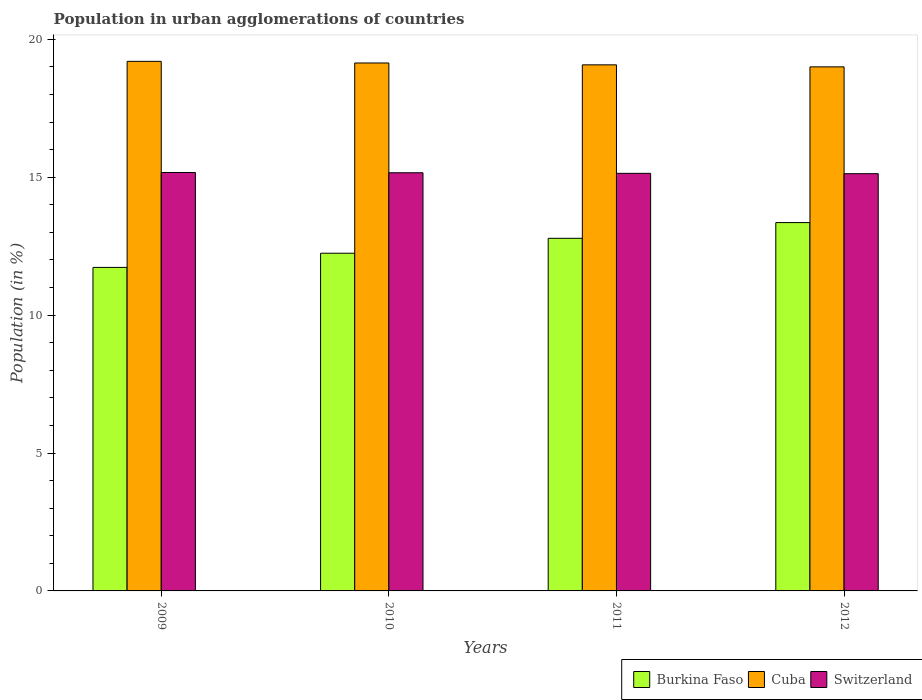How many different coloured bars are there?
Provide a short and direct response. 3. How many bars are there on the 2nd tick from the left?
Ensure brevity in your answer.  3. How many bars are there on the 3rd tick from the right?
Your response must be concise. 3. What is the label of the 4th group of bars from the left?
Offer a very short reply. 2012. In how many cases, is the number of bars for a given year not equal to the number of legend labels?
Keep it short and to the point. 0. What is the percentage of population in urban agglomerations in Switzerland in 2012?
Make the answer very short. 15.13. Across all years, what is the maximum percentage of population in urban agglomerations in Burkina Faso?
Keep it short and to the point. 13.36. Across all years, what is the minimum percentage of population in urban agglomerations in Burkina Faso?
Give a very brief answer. 11.73. In which year was the percentage of population in urban agglomerations in Cuba maximum?
Your response must be concise. 2009. What is the total percentage of population in urban agglomerations in Switzerland in the graph?
Provide a short and direct response. 60.61. What is the difference between the percentage of population in urban agglomerations in Switzerland in 2010 and that in 2012?
Give a very brief answer. 0.03. What is the difference between the percentage of population in urban agglomerations in Cuba in 2011 and the percentage of population in urban agglomerations in Switzerland in 2010?
Offer a very short reply. 3.91. What is the average percentage of population in urban agglomerations in Burkina Faso per year?
Your response must be concise. 12.53. In the year 2010, what is the difference between the percentage of population in urban agglomerations in Cuba and percentage of population in urban agglomerations in Burkina Faso?
Give a very brief answer. 6.9. What is the ratio of the percentage of population in urban agglomerations in Cuba in 2011 to that in 2012?
Offer a very short reply. 1. Is the difference between the percentage of population in urban agglomerations in Cuba in 2010 and 2011 greater than the difference between the percentage of population in urban agglomerations in Burkina Faso in 2010 and 2011?
Your answer should be very brief. Yes. What is the difference between the highest and the second highest percentage of population in urban agglomerations in Burkina Faso?
Keep it short and to the point. 0.57. What is the difference between the highest and the lowest percentage of population in urban agglomerations in Cuba?
Your answer should be compact. 0.2. Is the sum of the percentage of population in urban agglomerations in Cuba in 2010 and 2011 greater than the maximum percentage of population in urban agglomerations in Switzerland across all years?
Your answer should be very brief. Yes. What does the 2nd bar from the left in 2012 represents?
Your response must be concise. Cuba. What does the 2nd bar from the right in 2012 represents?
Your answer should be very brief. Cuba. Is it the case that in every year, the sum of the percentage of population in urban agglomerations in Cuba and percentage of population in urban agglomerations in Switzerland is greater than the percentage of population in urban agglomerations in Burkina Faso?
Give a very brief answer. Yes. How many bars are there?
Make the answer very short. 12. How many years are there in the graph?
Keep it short and to the point. 4. What is the difference between two consecutive major ticks on the Y-axis?
Provide a succinct answer. 5. Does the graph contain grids?
Make the answer very short. No. Where does the legend appear in the graph?
Give a very brief answer. Bottom right. How many legend labels are there?
Offer a terse response. 3. How are the legend labels stacked?
Provide a succinct answer. Horizontal. What is the title of the graph?
Offer a very short reply. Population in urban agglomerations of countries. Does "Malawi" appear as one of the legend labels in the graph?
Provide a short and direct response. No. What is the label or title of the X-axis?
Offer a very short reply. Years. What is the Population (in %) in Burkina Faso in 2009?
Your answer should be compact. 11.73. What is the Population (in %) in Cuba in 2009?
Provide a short and direct response. 19.2. What is the Population (in %) in Switzerland in 2009?
Offer a very short reply. 15.17. What is the Population (in %) of Burkina Faso in 2010?
Your answer should be compact. 12.25. What is the Population (in %) in Cuba in 2010?
Your answer should be very brief. 19.14. What is the Population (in %) in Switzerland in 2010?
Your response must be concise. 15.16. What is the Population (in %) in Burkina Faso in 2011?
Offer a very short reply. 12.79. What is the Population (in %) of Cuba in 2011?
Offer a very short reply. 19.08. What is the Population (in %) of Switzerland in 2011?
Provide a succinct answer. 15.14. What is the Population (in %) in Burkina Faso in 2012?
Your answer should be compact. 13.36. What is the Population (in %) in Cuba in 2012?
Offer a terse response. 19. What is the Population (in %) in Switzerland in 2012?
Keep it short and to the point. 15.13. Across all years, what is the maximum Population (in %) in Burkina Faso?
Provide a succinct answer. 13.36. Across all years, what is the maximum Population (in %) of Cuba?
Your response must be concise. 19.2. Across all years, what is the maximum Population (in %) of Switzerland?
Make the answer very short. 15.17. Across all years, what is the minimum Population (in %) in Burkina Faso?
Provide a short and direct response. 11.73. Across all years, what is the minimum Population (in %) of Cuba?
Keep it short and to the point. 19. Across all years, what is the minimum Population (in %) in Switzerland?
Keep it short and to the point. 15.13. What is the total Population (in %) of Burkina Faso in the graph?
Provide a succinct answer. 50.12. What is the total Population (in %) in Cuba in the graph?
Your response must be concise. 76.42. What is the total Population (in %) of Switzerland in the graph?
Ensure brevity in your answer.  60.61. What is the difference between the Population (in %) in Burkina Faso in 2009 and that in 2010?
Provide a succinct answer. -0.51. What is the difference between the Population (in %) in Cuba in 2009 and that in 2010?
Provide a succinct answer. 0.06. What is the difference between the Population (in %) of Burkina Faso in 2009 and that in 2011?
Your answer should be very brief. -1.06. What is the difference between the Population (in %) of Cuba in 2009 and that in 2011?
Give a very brief answer. 0.13. What is the difference between the Population (in %) of Switzerland in 2009 and that in 2011?
Provide a short and direct response. 0.03. What is the difference between the Population (in %) of Burkina Faso in 2009 and that in 2012?
Offer a very short reply. -1.63. What is the difference between the Population (in %) in Cuba in 2009 and that in 2012?
Your response must be concise. 0.2. What is the difference between the Population (in %) in Switzerland in 2009 and that in 2012?
Make the answer very short. 0.04. What is the difference between the Population (in %) in Burkina Faso in 2010 and that in 2011?
Keep it short and to the point. -0.54. What is the difference between the Population (in %) in Cuba in 2010 and that in 2011?
Your response must be concise. 0.07. What is the difference between the Population (in %) of Switzerland in 2010 and that in 2011?
Make the answer very short. 0.02. What is the difference between the Population (in %) in Burkina Faso in 2010 and that in 2012?
Your answer should be very brief. -1.11. What is the difference between the Population (in %) in Cuba in 2010 and that in 2012?
Your response must be concise. 0.14. What is the difference between the Population (in %) of Switzerland in 2010 and that in 2012?
Offer a terse response. 0.03. What is the difference between the Population (in %) in Burkina Faso in 2011 and that in 2012?
Give a very brief answer. -0.57. What is the difference between the Population (in %) of Cuba in 2011 and that in 2012?
Make the answer very short. 0.07. What is the difference between the Population (in %) of Switzerland in 2011 and that in 2012?
Make the answer very short. 0.01. What is the difference between the Population (in %) in Burkina Faso in 2009 and the Population (in %) in Cuba in 2010?
Give a very brief answer. -7.41. What is the difference between the Population (in %) of Burkina Faso in 2009 and the Population (in %) of Switzerland in 2010?
Provide a short and direct response. -3.43. What is the difference between the Population (in %) of Cuba in 2009 and the Population (in %) of Switzerland in 2010?
Give a very brief answer. 4.04. What is the difference between the Population (in %) in Burkina Faso in 2009 and the Population (in %) in Cuba in 2011?
Your response must be concise. -7.35. What is the difference between the Population (in %) in Burkina Faso in 2009 and the Population (in %) in Switzerland in 2011?
Ensure brevity in your answer.  -3.41. What is the difference between the Population (in %) of Cuba in 2009 and the Population (in %) of Switzerland in 2011?
Provide a short and direct response. 4.06. What is the difference between the Population (in %) in Burkina Faso in 2009 and the Population (in %) in Cuba in 2012?
Offer a terse response. -7.27. What is the difference between the Population (in %) in Burkina Faso in 2009 and the Population (in %) in Switzerland in 2012?
Keep it short and to the point. -3.4. What is the difference between the Population (in %) of Cuba in 2009 and the Population (in %) of Switzerland in 2012?
Ensure brevity in your answer.  4.07. What is the difference between the Population (in %) in Burkina Faso in 2010 and the Population (in %) in Cuba in 2011?
Offer a terse response. -6.83. What is the difference between the Population (in %) in Burkina Faso in 2010 and the Population (in %) in Switzerland in 2011?
Provide a short and direct response. -2.9. What is the difference between the Population (in %) in Cuba in 2010 and the Population (in %) in Switzerland in 2011?
Your answer should be very brief. 4. What is the difference between the Population (in %) of Burkina Faso in 2010 and the Population (in %) of Cuba in 2012?
Ensure brevity in your answer.  -6.76. What is the difference between the Population (in %) of Burkina Faso in 2010 and the Population (in %) of Switzerland in 2012?
Provide a short and direct response. -2.88. What is the difference between the Population (in %) of Cuba in 2010 and the Population (in %) of Switzerland in 2012?
Your answer should be very brief. 4.01. What is the difference between the Population (in %) in Burkina Faso in 2011 and the Population (in %) in Cuba in 2012?
Ensure brevity in your answer.  -6.22. What is the difference between the Population (in %) of Burkina Faso in 2011 and the Population (in %) of Switzerland in 2012?
Offer a terse response. -2.34. What is the difference between the Population (in %) of Cuba in 2011 and the Population (in %) of Switzerland in 2012?
Offer a very short reply. 3.95. What is the average Population (in %) in Burkina Faso per year?
Your answer should be compact. 12.53. What is the average Population (in %) in Cuba per year?
Offer a very short reply. 19.11. What is the average Population (in %) in Switzerland per year?
Offer a terse response. 15.15. In the year 2009, what is the difference between the Population (in %) of Burkina Faso and Population (in %) of Cuba?
Keep it short and to the point. -7.47. In the year 2009, what is the difference between the Population (in %) in Burkina Faso and Population (in %) in Switzerland?
Keep it short and to the point. -3.44. In the year 2009, what is the difference between the Population (in %) of Cuba and Population (in %) of Switzerland?
Your answer should be very brief. 4.03. In the year 2010, what is the difference between the Population (in %) of Burkina Faso and Population (in %) of Cuba?
Offer a very short reply. -6.9. In the year 2010, what is the difference between the Population (in %) in Burkina Faso and Population (in %) in Switzerland?
Provide a short and direct response. -2.92. In the year 2010, what is the difference between the Population (in %) of Cuba and Population (in %) of Switzerland?
Ensure brevity in your answer.  3.98. In the year 2011, what is the difference between the Population (in %) of Burkina Faso and Population (in %) of Cuba?
Ensure brevity in your answer.  -6.29. In the year 2011, what is the difference between the Population (in %) of Burkina Faso and Population (in %) of Switzerland?
Your answer should be very brief. -2.36. In the year 2011, what is the difference between the Population (in %) of Cuba and Population (in %) of Switzerland?
Offer a very short reply. 3.93. In the year 2012, what is the difference between the Population (in %) in Burkina Faso and Population (in %) in Cuba?
Your response must be concise. -5.65. In the year 2012, what is the difference between the Population (in %) in Burkina Faso and Population (in %) in Switzerland?
Offer a terse response. -1.77. In the year 2012, what is the difference between the Population (in %) of Cuba and Population (in %) of Switzerland?
Keep it short and to the point. 3.87. What is the ratio of the Population (in %) in Burkina Faso in 2009 to that in 2010?
Offer a very short reply. 0.96. What is the ratio of the Population (in %) of Cuba in 2009 to that in 2010?
Offer a very short reply. 1. What is the ratio of the Population (in %) in Switzerland in 2009 to that in 2010?
Provide a short and direct response. 1. What is the ratio of the Population (in %) in Burkina Faso in 2009 to that in 2011?
Provide a short and direct response. 0.92. What is the ratio of the Population (in %) in Cuba in 2009 to that in 2011?
Your answer should be compact. 1.01. What is the ratio of the Population (in %) of Switzerland in 2009 to that in 2011?
Provide a short and direct response. 1. What is the ratio of the Population (in %) of Burkina Faso in 2009 to that in 2012?
Provide a short and direct response. 0.88. What is the ratio of the Population (in %) of Cuba in 2009 to that in 2012?
Offer a terse response. 1.01. What is the ratio of the Population (in %) in Switzerland in 2009 to that in 2012?
Your answer should be compact. 1. What is the ratio of the Population (in %) in Burkina Faso in 2010 to that in 2011?
Your answer should be very brief. 0.96. What is the ratio of the Population (in %) of Cuba in 2010 to that in 2011?
Ensure brevity in your answer.  1. What is the ratio of the Population (in %) in Burkina Faso in 2010 to that in 2012?
Offer a very short reply. 0.92. What is the ratio of the Population (in %) in Cuba in 2010 to that in 2012?
Give a very brief answer. 1.01. What is the ratio of the Population (in %) in Switzerland in 2010 to that in 2012?
Your response must be concise. 1. What is the ratio of the Population (in %) of Burkina Faso in 2011 to that in 2012?
Provide a succinct answer. 0.96. What is the ratio of the Population (in %) in Cuba in 2011 to that in 2012?
Offer a terse response. 1. What is the ratio of the Population (in %) of Switzerland in 2011 to that in 2012?
Provide a short and direct response. 1. What is the difference between the highest and the second highest Population (in %) in Burkina Faso?
Your answer should be compact. 0.57. What is the difference between the highest and the second highest Population (in %) in Cuba?
Provide a short and direct response. 0.06. What is the difference between the highest and the second highest Population (in %) in Switzerland?
Provide a short and direct response. 0.01. What is the difference between the highest and the lowest Population (in %) in Burkina Faso?
Offer a very short reply. 1.63. What is the difference between the highest and the lowest Population (in %) of Cuba?
Your answer should be compact. 0.2. What is the difference between the highest and the lowest Population (in %) of Switzerland?
Make the answer very short. 0.04. 